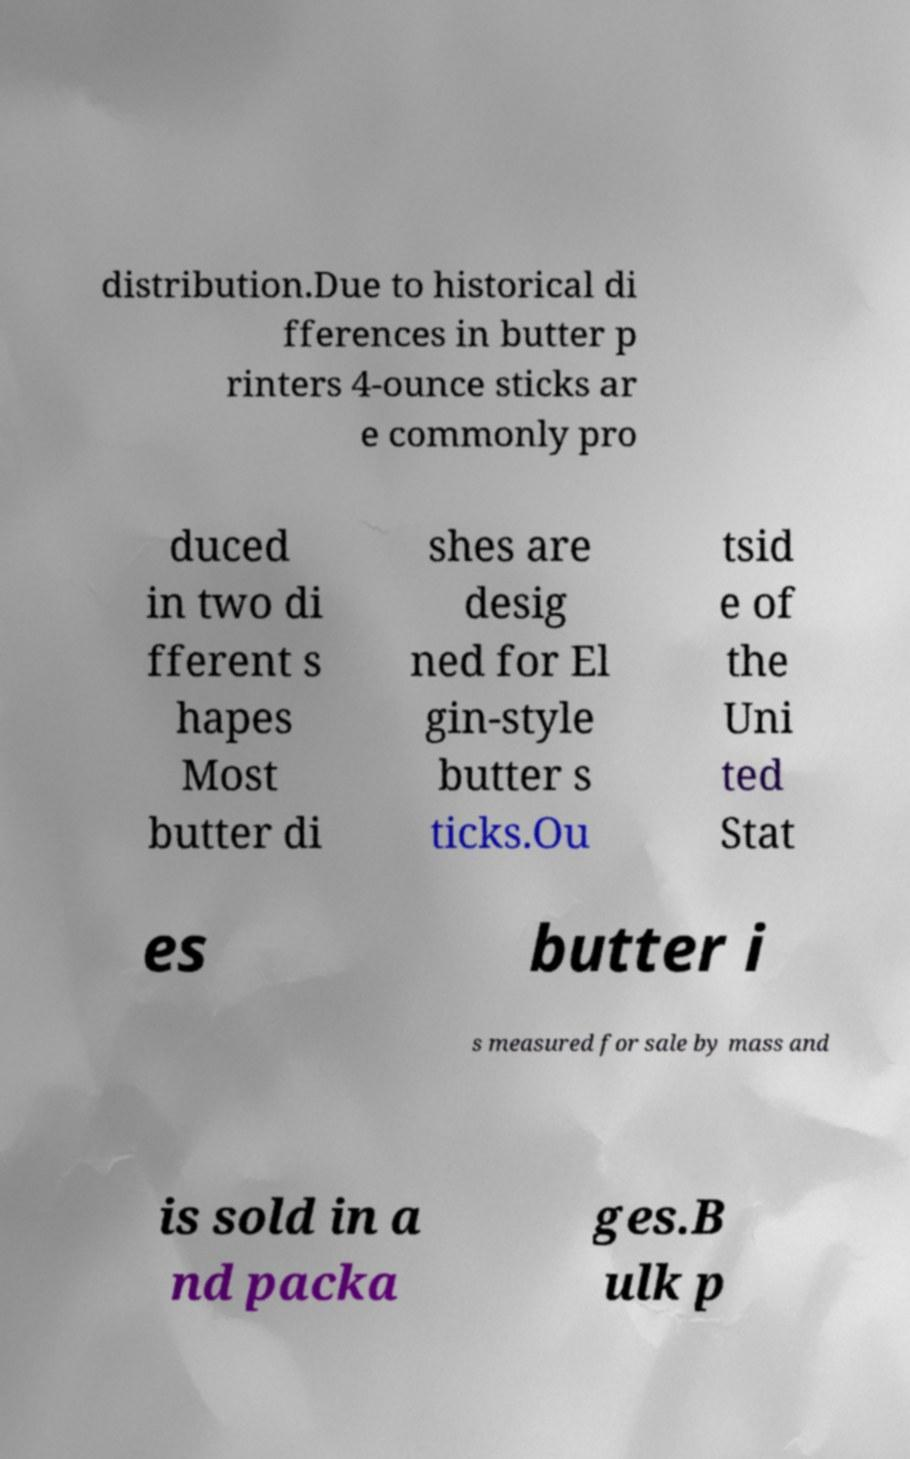Can you accurately transcribe the text from the provided image for me? distribution.Due to historical di fferences in butter p rinters 4-ounce sticks ar e commonly pro duced in two di fferent s hapes Most butter di shes are desig ned for El gin-style butter s ticks.Ou tsid e of the Uni ted Stat es butter i s measured for sale by mass and is sold in a nd packa ges.B ulk p 